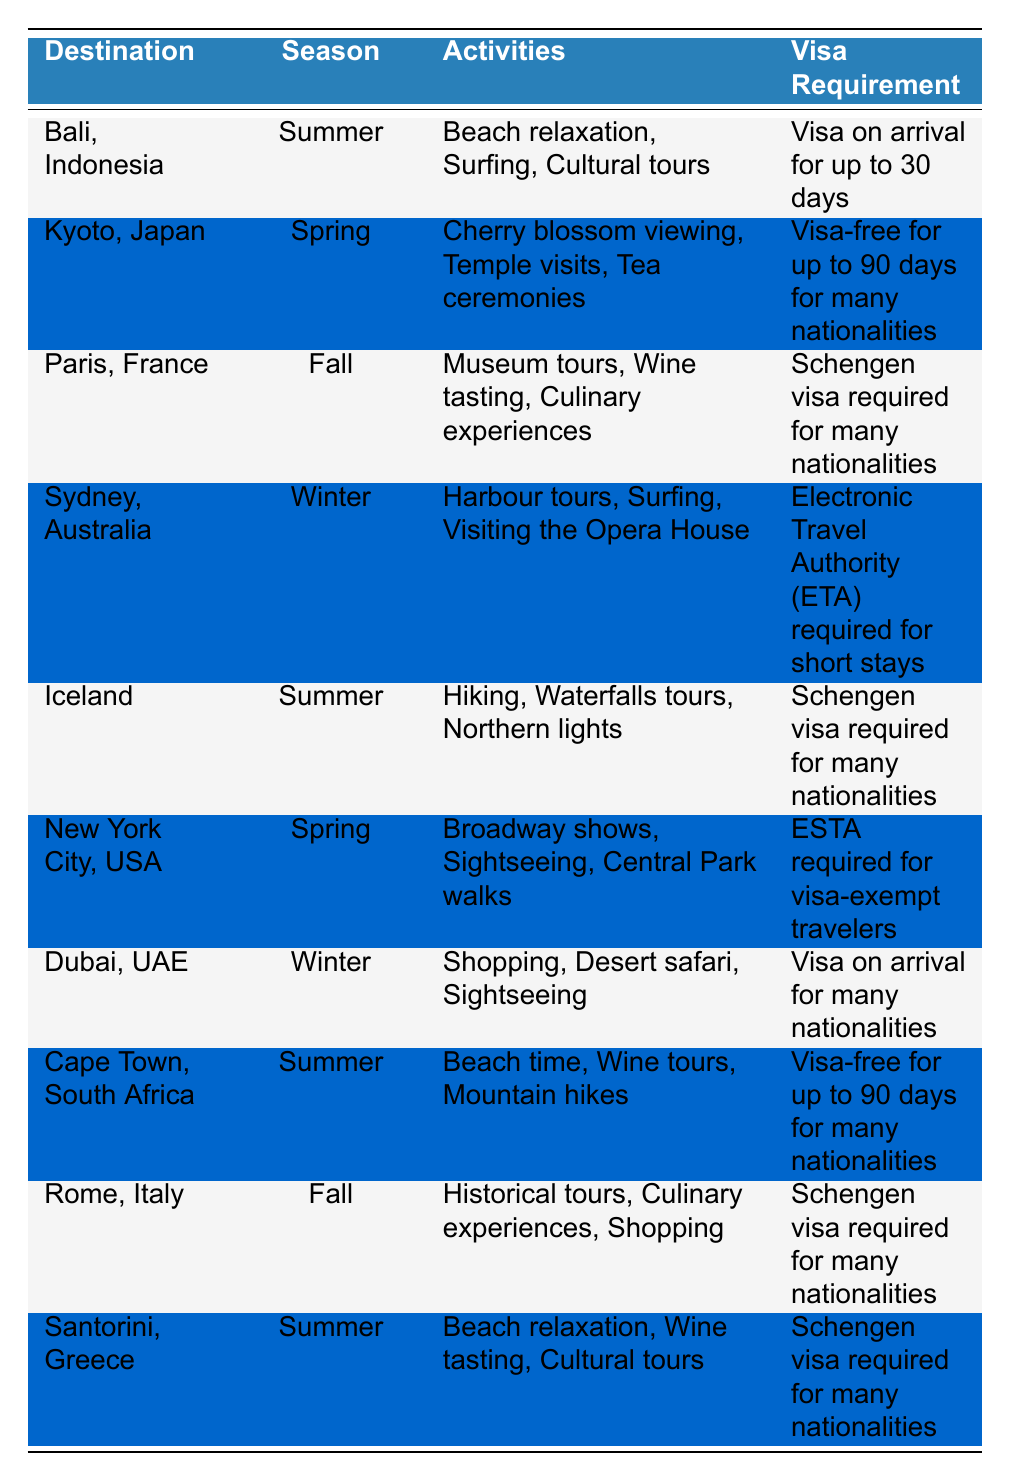What is the visa requirement for Santorini, Greece? The table shows the visa requirement for Santorini, Greece under the Visa Requirement column, which specifies it as a Schengen visa required for many nationalities.
Answer: Schengen visa required for many nationalities Which destination is known for cherry blossom viewing? In the table, the destination with cherry blossom viewing is listed under the Spring season, which corresponds to Kyoto, Japan.
Answer: Kyoto, Japan How many destinations require a Schengen visa? The table lists three destinations with Schengen visa requirements: Paris, France; Rome, Italy; and Santorini, Greece. This totals three destinations.
Answer: Three Is New York City a summer destination according to the table? In the table, New York City is listed under Spring, so it is not categorized as a summer destination.
Answer: No What are the activities in Bali, Indonesia? The activities associated with Bali, Indonesia can be found in the Activities column, which lists Beach relaxation, Surfing, and Cultural tours.
Answer: Beach relaxation, Surfing, Cultural tours Which destination requires an Electronic Travel Authority (ETA) for short stays? The table indicates that Sydney, Australia requires an Electronic Travel Authority (ETA) for short stays, as noted in the Visa Requirement column.
Answer: Sydney, Australia How many destinations are identified for the Summer season? The table identifies four destinations for the Summer season: Bali, Indonesia; Iceland; Cape Town, South Africa; and Santorini, Greece, making a total of four.
Answer: Four What is the primary activity listed for Dubai, UAE? For Dubai, UAE, the primary activities listed in the Activities column include Shopping, Desert safari, and Sightseeing, making these the main activities associated with this destination.
Answer: Shopping, Desert safari, Sightseeing If a couple wants to visit a beach destination in Winter, which place can they choose? The table shows that Dubai, UAE and Sydney, Australia both feature activities that include beach-related experiences in the Winter season. Therefore, these are suitable winter beach destinations.
Answer: Dubai, UAE; Sydney, Australia Which destination offers wine tours in the Summer? The table mentions Cape Town, South Africa as having wine tours listed under the Activities column specifically for the Summer season.
Answer: Cape Town, South Africa 